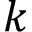Convert formula to latex. <formula><loc_0><loc_0><loc_500><loc_500>k</formula> 